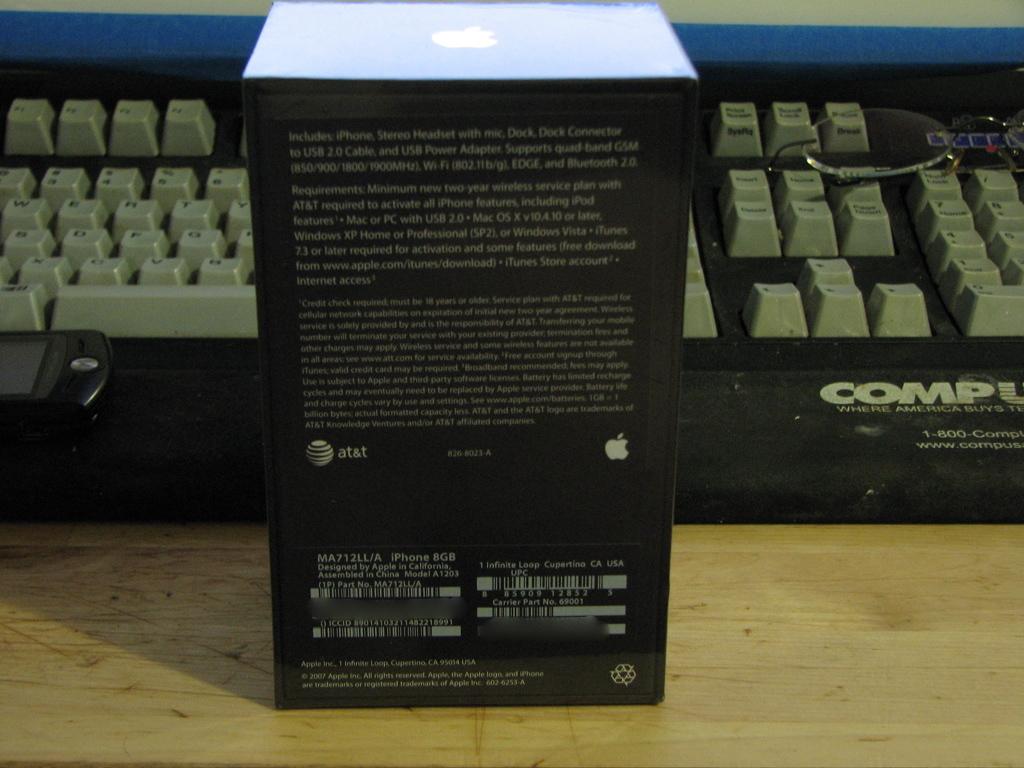What company is on the left side of the box?
Keep it short and to the point. At&t. 